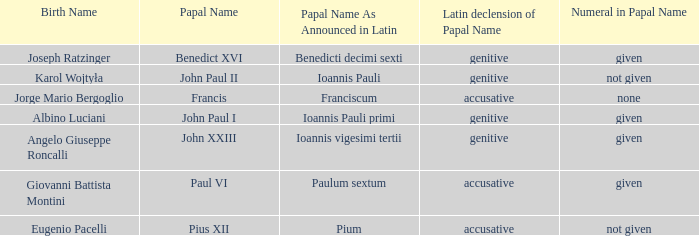For Pope Paul VI, what is the declension of his papal name? Accusative. 